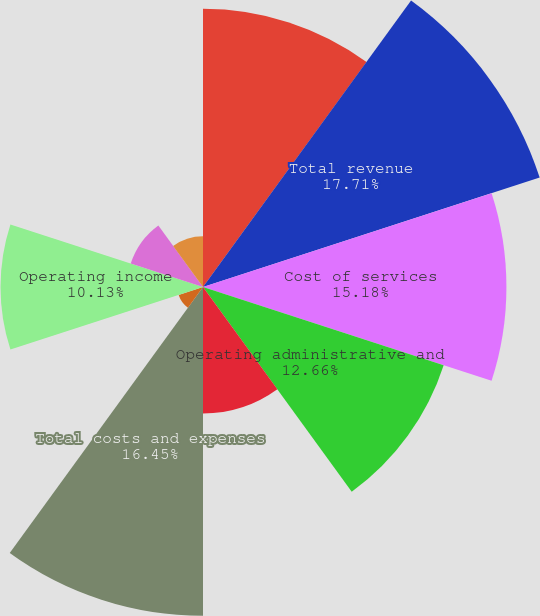Convert chart to OTSL. <chart><loc_0><loc_0><loc_500><loc_500><pie_chart><fcel>Pass through costs also<fcel>Total revenue<fcel>Cost of services<fcel>Operating administrative and<fcel>Depreciation and amortization<fcel>Total costs and expenses<fcel>Gain on disposition of real<fcel>Operating income<fcel>Equity income from<fcel>Interest expense<nl><fcel>13.92%<fcel>17.71%<fcel>15.18%<fcel>12.66%<fcel>6.33%<fcel>16.45%<fcel>1.28%<fcel>10.13%<fcel>3.8%<fcel>2.54%<nl></chart> 